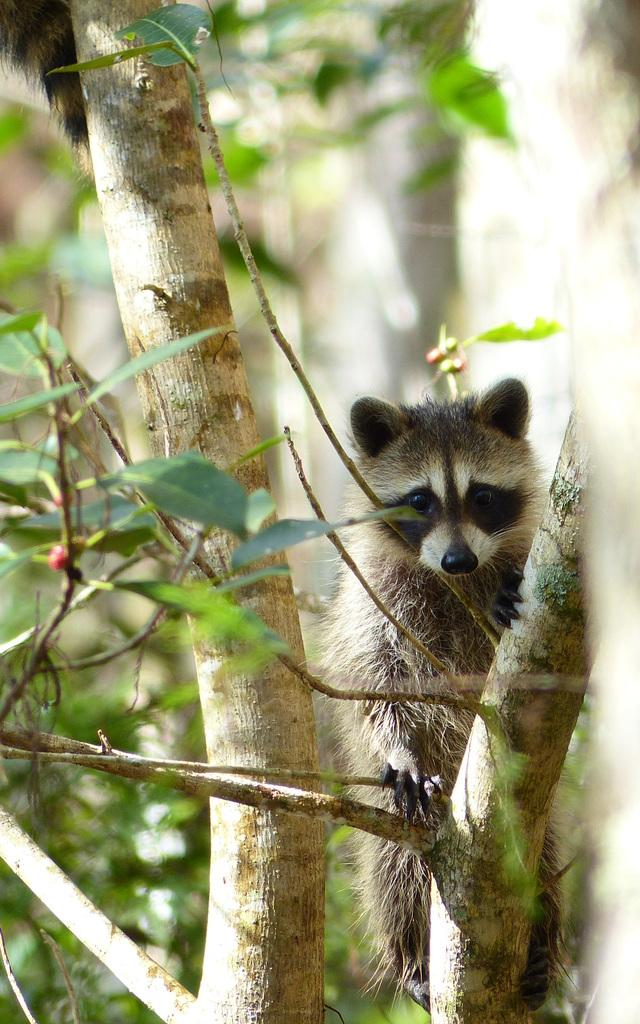How many animals are present in the image? There are two animals in the image. What are the animals doing in the image? The animals are standing on a tree. Can you describe the background of the image? The background of the image is blurry. What type of earth can be seen in the image? There is no earth visible in the image; the animals are standing on a tree. Are there any rats present in the image? There is no mention of rats in the image; it features two animals standing on a tree. 